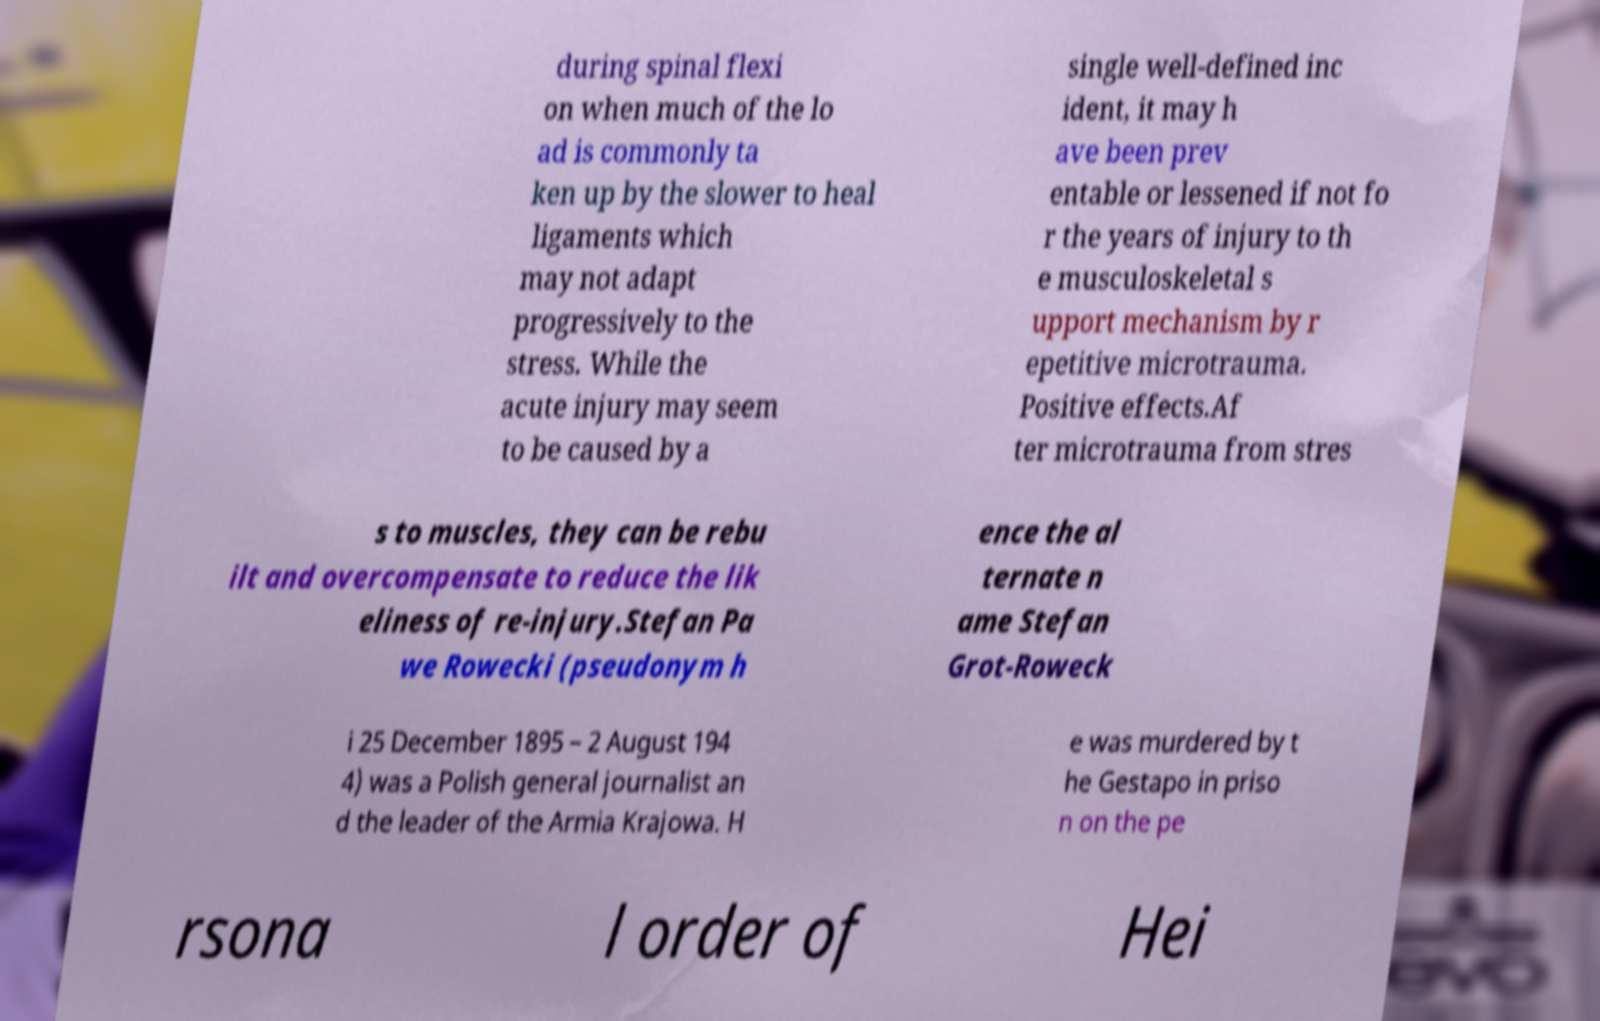Can you read and provide the text displayed in the image?This photo seems to have some interesting text. Can you extract and type it out for me? during spinal flexi on when much of the lo ad is commonly ta ken up by the slower to heal ligaments which may not adapt progressively to the stress. While the acute injury may seem to be caused by a single well-defined inc ident, it may h ave been prev entable or lessened if not fo r the years of injury to th e musculoskeletal s upport mechanism by r epetitive microtrauma. Positive effects.Af ter microtrauma from stres s to muscles, they can be rebu ilt and overcompensate to reduce the lik eliness of re-injury.Stefan Pa we Rowecki (pseudonym h ence the al ternate n ame Stefan Grot-Roweck i 25 December 1895 – 2 August 194 4) was a Polish general journalist an d the leader of the Armia Krajowa. H e was murdered by t he Gestapo in priso n on the pe rsona l order of Hei 